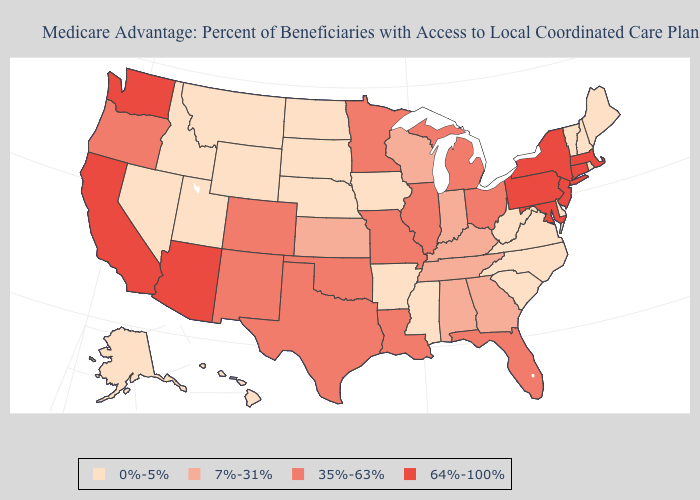Does Michigan have the lowest value in the MidWest?
Quick response, please. No. Name the states that have a value in the range 35%-63%?
Answer briefly. Colorado, Florida, Illinois, Louisiana, Michigan, Minnesota, Missouri, New Mexico, Ohio, Oklahoma, Oregon, Texas. Does South Dakota have a lower value than North Carolina?
Short answer required. No. Name the states that have a value in the range 35%-63%?
Answer briefly. Colorado, Florida, Illinois, Louisiana, Michigan, Minnesota, Missouri, New Mexico, Ohio, Oklahoma, Oregon, Texas. Name the states that have a value in the range 7%-31%?
Quick response, please. Alabama, Georgia, Indiana, Kansas, Kentucky, Tennessee, Wisconsin. What is the lowest value in the South?
Concise answer only. 0%-5%. What is the value of Alaska?
Keep it brief. 0%-5%. Which states have the highest value in the USA?
Write a very short answer. Arizona, California, Connecticut, Massachusetts, Maryland, New Jersey, New York, Pennsylvania, Washington. Does Utah have a lower value than Oregon?
Quick response, please. Yes. Among the states that border West Virginia , which have the highest value?
Short answer required. Maryland, Pennsylvania. What is the highest value in the West ?
Quick response, please. 64%-100%. Does Kansas have the same value as Minnesota?
Short answer required. No. What is the value of New Hampshire?
Short answer required. 0%-5%. Name the states that have a value in the range 64%-100%?
Answer briefly. Arizona, California, Connecticut, Massachusetts, Maryland, New Jersey, New York, Pennsylvania, Washington. 